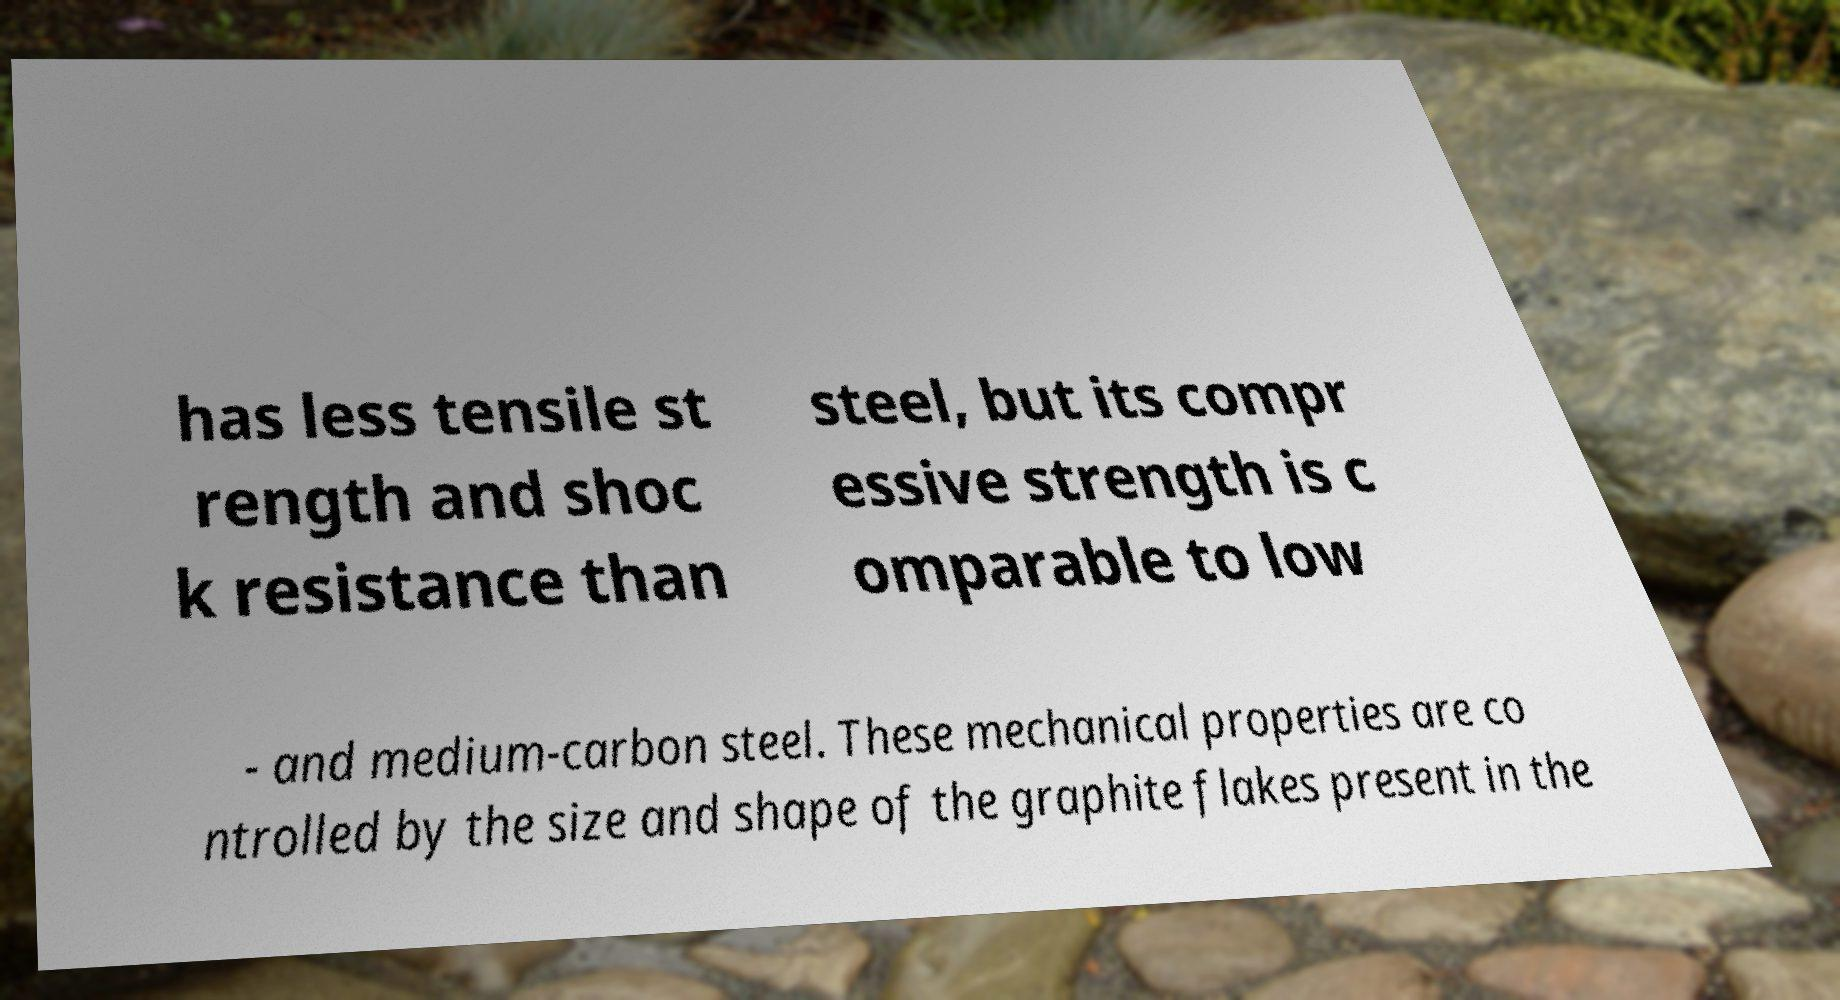There's text embedded in this image that I need extracted. Can you transcribe it verbatim? has less tensile st rength and shoc k resistance than steel, but its compr essive strength is c omparable to low - and medium-carbon steel. These mechanical properties are co ntrolled by the size and shape of the graphite flakes present in the 